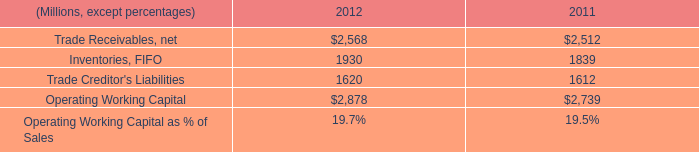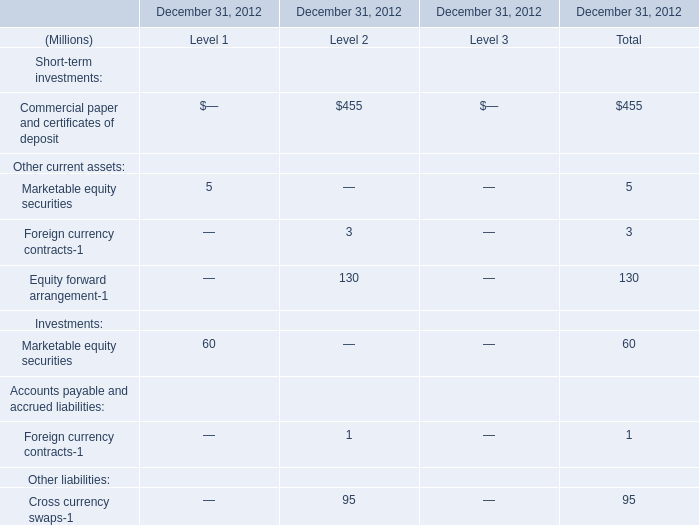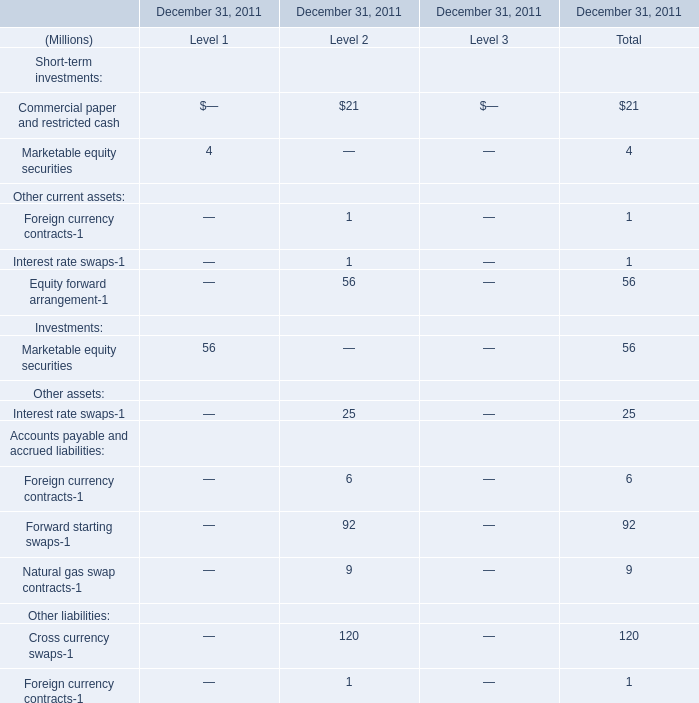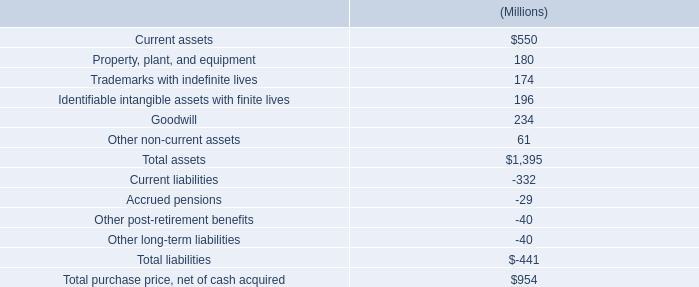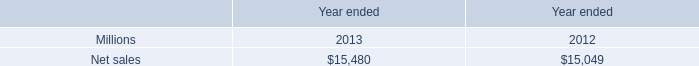what was the average cost per share for the share repurchases in 2012? 
Computations: (92 / 1)
Answer: 92.0. 